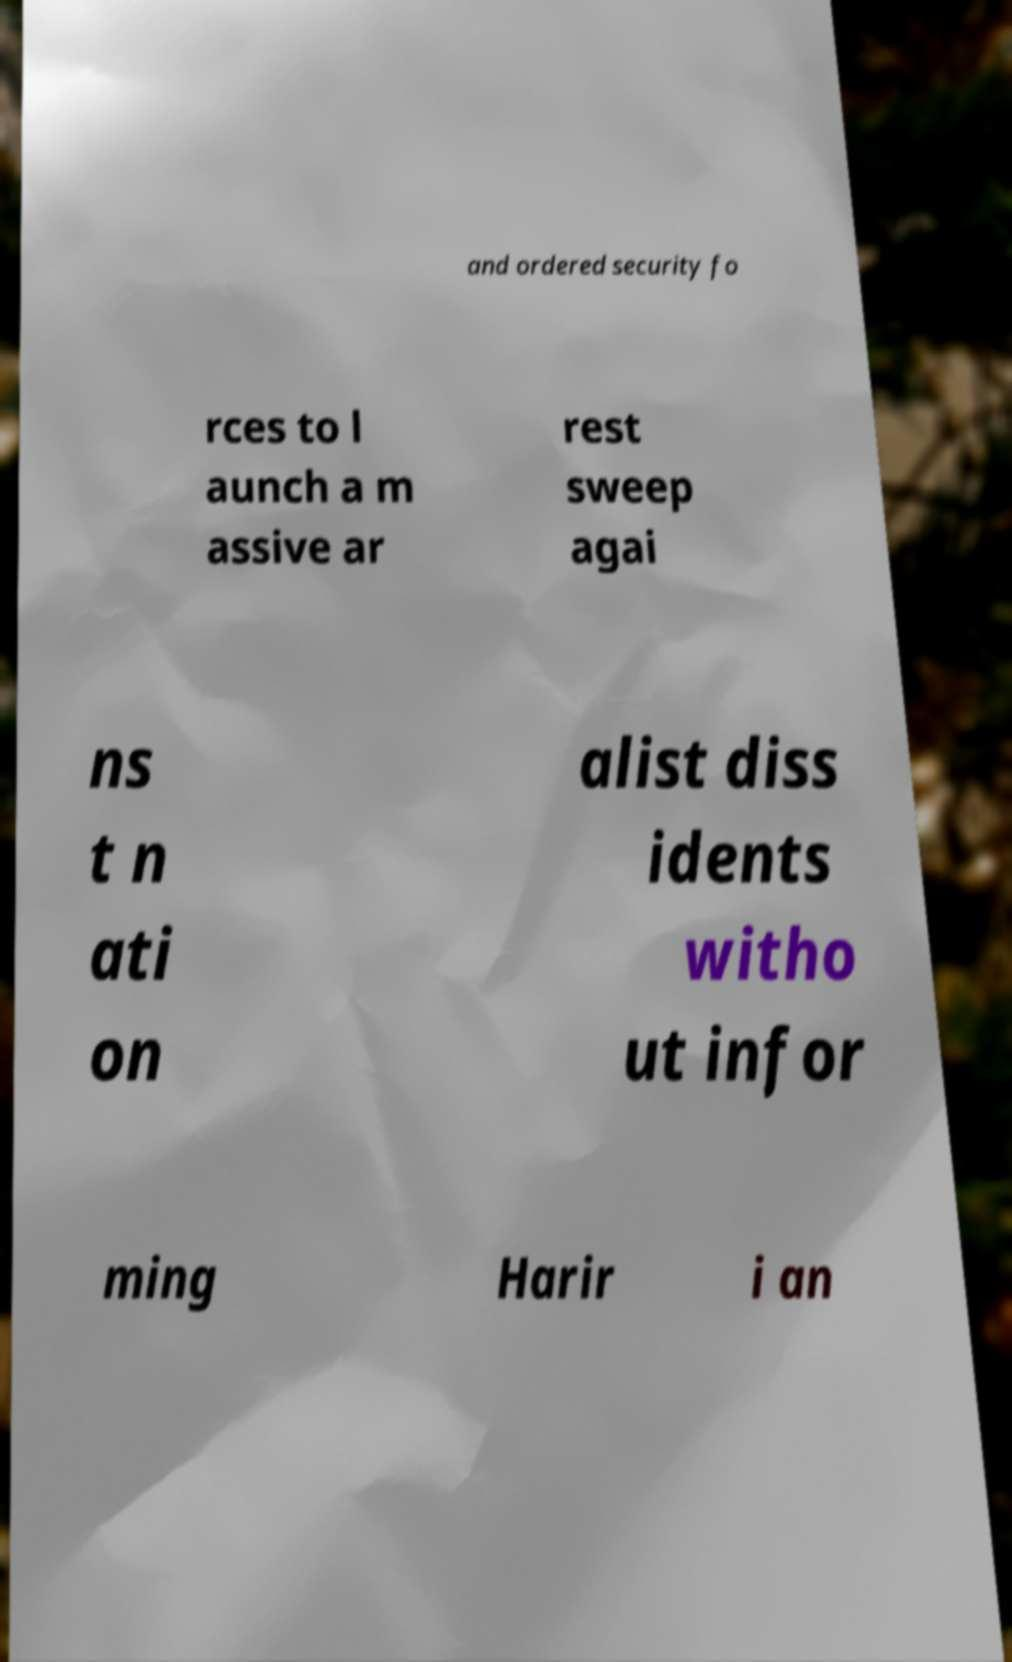Please identify and transcribe the text found in this image. and ordered security fo rces to l aunch a m assive ar rest sweep agai ns t n ati on alist diss idents witho ut infor ming Harir i an 